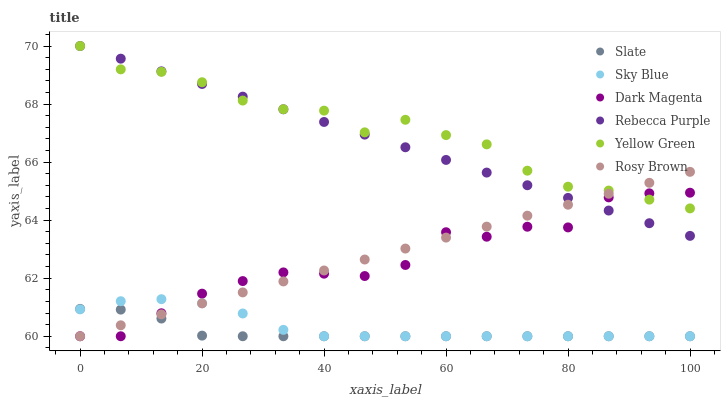Does Slate have the minimum area under the curve?
Answer yes or no. Yes. Does Yellow Green have the maximum area under the curve?
Answer yes or no. Yes. Does Rosy Brown have the minimum area under the curve?
Answer yes or no. No. Does Rosy Brown have the maximum area under the curve?
Answer yes or no. No. Is Rebecca Purple the smoothest?
Answer yes or no. Yes. Is Dark Magenta the roughest?
Answer yes or no. Yes. Is Slate the smoothest?
Answer yes or no. No. Is Slate the roughest?
Answer yes or no. No. Does Slate have the lowest value?
Answer yes or no. Yes. Does Rebecca Purple have the lowest value?
Answer yes or no. No. Does Rebecca Purple have the highest value?
Answer yes or no. Yes. Does Rosy Brown have the highest value?
Answer yes or no. No. Is Slate less than Rebecca Purple?
Answer yes or no. Yes. Is Yellow Green greater than Slate?
Answer yes or no. Yes. Does Rosy Brown intersect Yellow Green?
Answer yes or no. Yes. Is Rosy Brown less than Yellow Green?
Answer yes or no. No. Is Rosy Brown greater than Yellow Green?
Answer yes or no. No. Does Slate intersect Rebecca Purple?
Answer yes or no. No. 